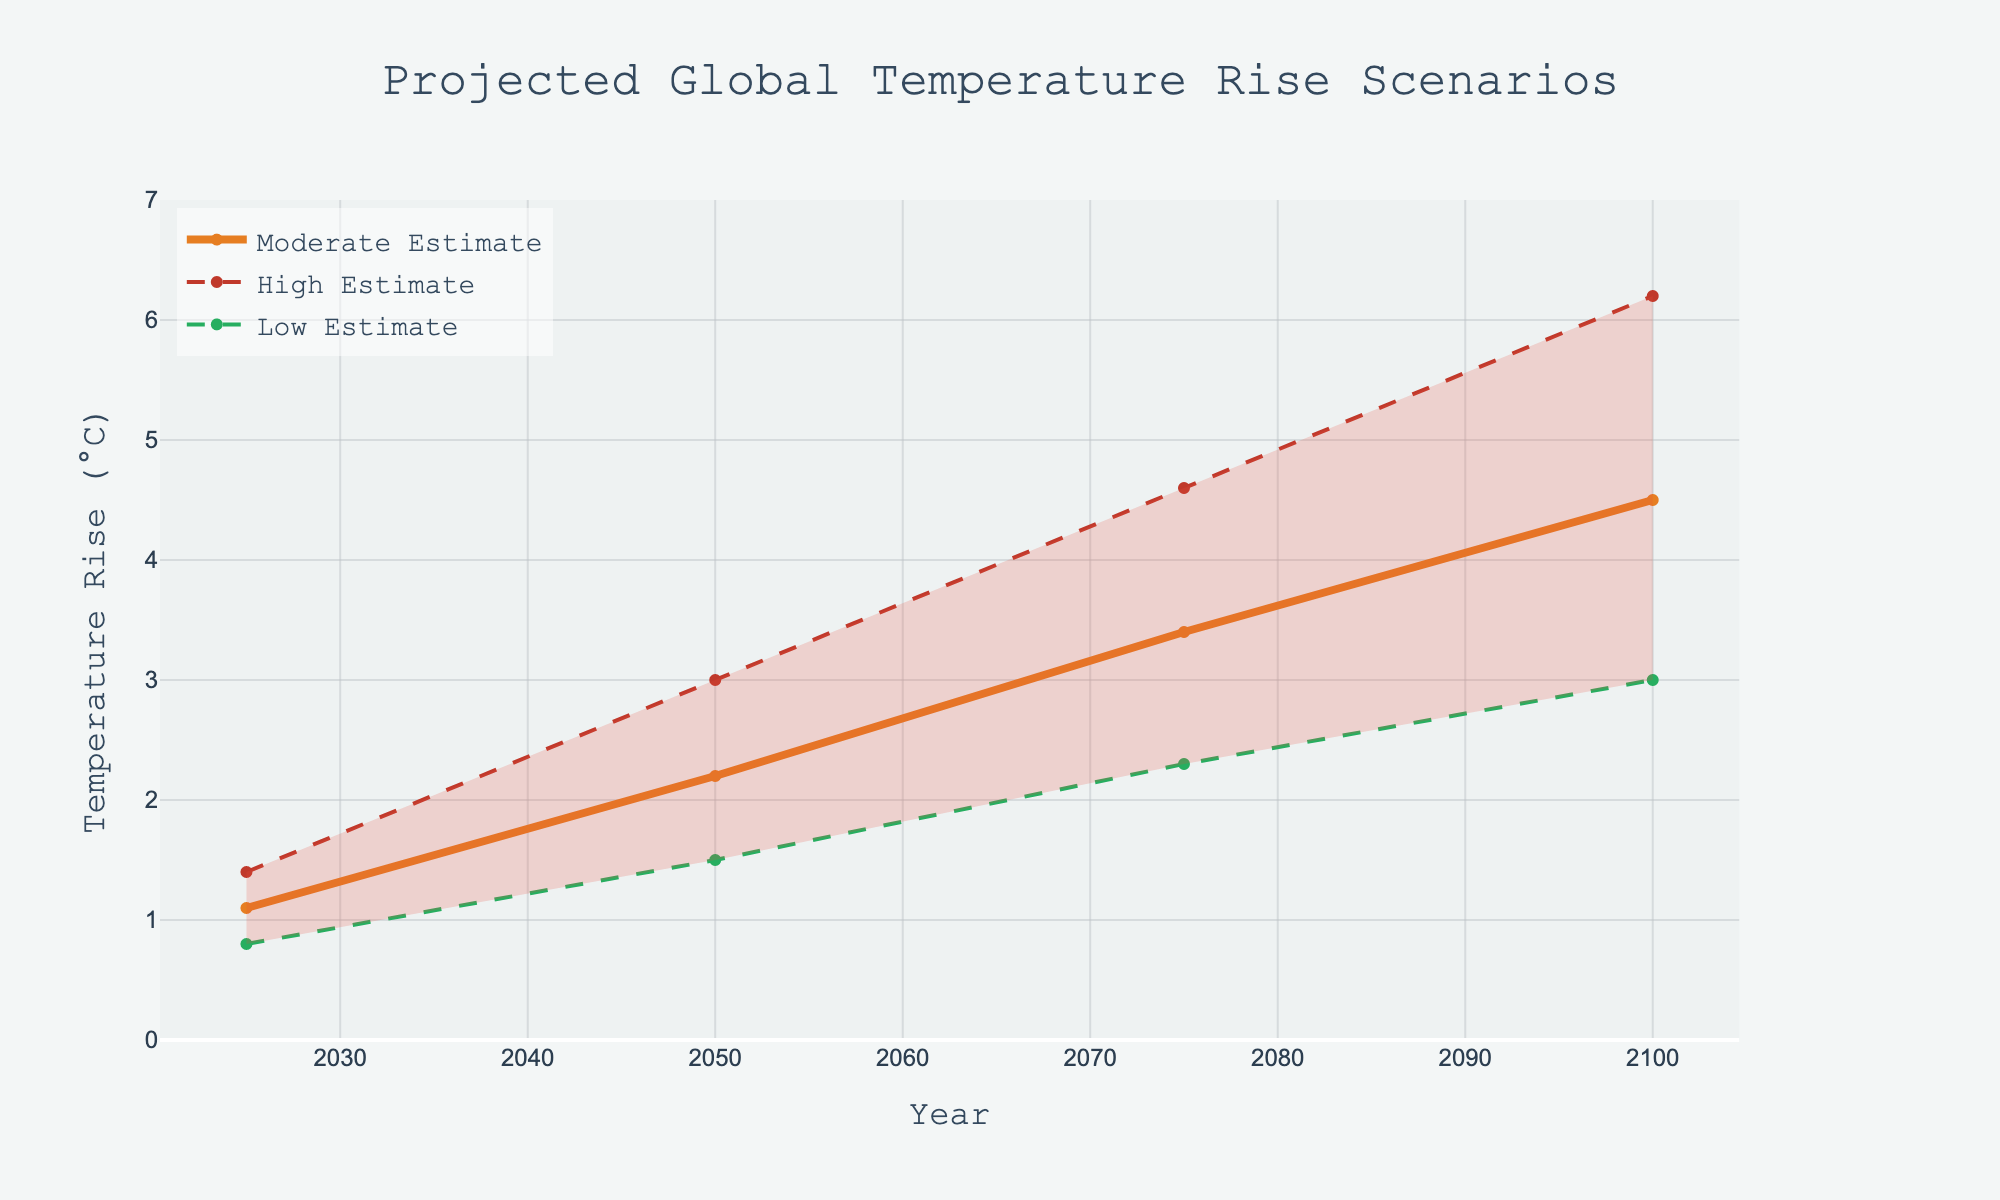What is the title of the plot? The title is typically at the top of the plot, centered and larger in font. It summarizes the overall content of the graph. Here, it reads "Projected Global Temperature Rise Scenarios".
Answer: Projected Global Temperature Rise Scenarios What do the x-axis and y-axis represent? The x-axis is labeled "Year", indicating it shows the progression of time, while the y-axis is labeled "Temperature Rise (°C)", indicating it shows the projected increase in global temperature in degrees Celsius.
Answer: Year; Temperature Rise (°C) How many projection lines are shown in the plot and what do they represent? There are three lines, each representing different projections: a green line for the Low Estimate, an orange line for the Moderate Estimate, and a red dashed line for the High Estimate.
Answer: Three; Low Estimate, Moderate Estimate, High Estimate What is the temperature range projected for the year 2100 according to the plot? The uncertainty range for 2100 can be found by noting the highest value of the High Estimate and the lowest value of the Low Estimate for that year. The graph shows that the Low Estimate is 3.0°C, and the High Estimate is 6.2°C.
Answer: 3.0°C to 6.2°C Compare the Moderate Estimate and the Low Estimate for the year 2050. How much higher is the Moderate Estimate? Locate the values for both estimates at the year 2050. The Moderate Estimate is 2.2°C, and the Low Estimate is 1.5°C. Subtract the Low Estimate from the Moderate Estimate: 2.2 - 1.5 = 0.7°C.
Answer: 0.7°C By how much is the projected temperature rise in 2075 higher in the High Estimate compared to the Low Estimate? Check the values at the year 2075 for both High Estimate and Low Estimate lines. The High Estimate is 4.6°C, and the Low Estimate is 2.3°C. Subtract the Low from the High Estimate: 4.6 - 2.3 = 2.3°C.
Answer: 2.3°C What is the maximum projected temperature rise according to the data, and in which year does it occur? The maximum projected temperature rise is found on the High Estimate line. The highest value is at the year 2100, at 6.2°C.
Answer: 6.2°C; 2100 What general trend can you infer from the graph regarding global temperature rise over the next century? All three projection lines - Low, Moderate, and High Estimates - show an increasing trend over time, indicating a consistent rise in global temperatures through 2100.
Answer: Increasing trend For which years does the uncertainty range overlap between the Low and High Estimates? The entire range between the years 2025 and 2100 sees an overlap since the filled area between the Low and High Estimates runs continuously for all these years.
Answer: 2025 to 2100 Which estimate line appears the least variable and why? The Low Estimate line seems the least variable as it rises consistently without much deviation, unlike the High Estimate, which has more significant fluctuations.
Answer: Low Estimate; it is the smoothest and least volatile 